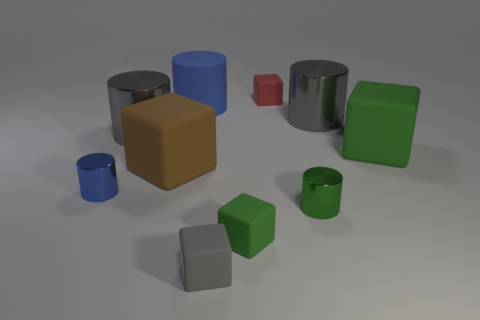Do the green thing that is behind the large brown rubber object and the green thing to the left of the red thing have the same material?
Your answer should be very brief. Yes. There is a small green object that is the same shape as the brown thing; what material is it?
Give a very brief answer. Rubber. Do the brown thing and the big blue thing have the same material?
Your answer should be very brief. Yes. There is a tiny metallic cylinder right of the large cube to the left of the large blue cylinder; what is its color?
Keep it short and to the point. Green. What size is the blue cylinder that is made of the same material as the gray cube?
Ensure brevity in your answer.  Large. How many big green objects are the same shape as the tiny blue shiny object?
Make the answer very short. 0. How many objects are big gray metal things to the left of the large brown matte block or gray cylinders right of the small green rubber object?
Provide a succinct answer. 2. How many tiny gray blocks are behind the big gray cylinder to the left of the red matte thing?
Give a very brief answer. 0. There is a green rubber object to the right of the tiny red object; is its shape the same as the tiny object behind the blue matte cylinder?
Offer a very short reply. Yes. Is there a thing made of the same material as the green cylinder?
Your answer should be very brief. Yes. 